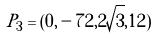<formula> <loc_0><loc_0><loc_500><loc_500>P _ { 3 } = ( 0 , - 7 2 , 2 \sqrt { 3 } , 1 2 )</formula> 